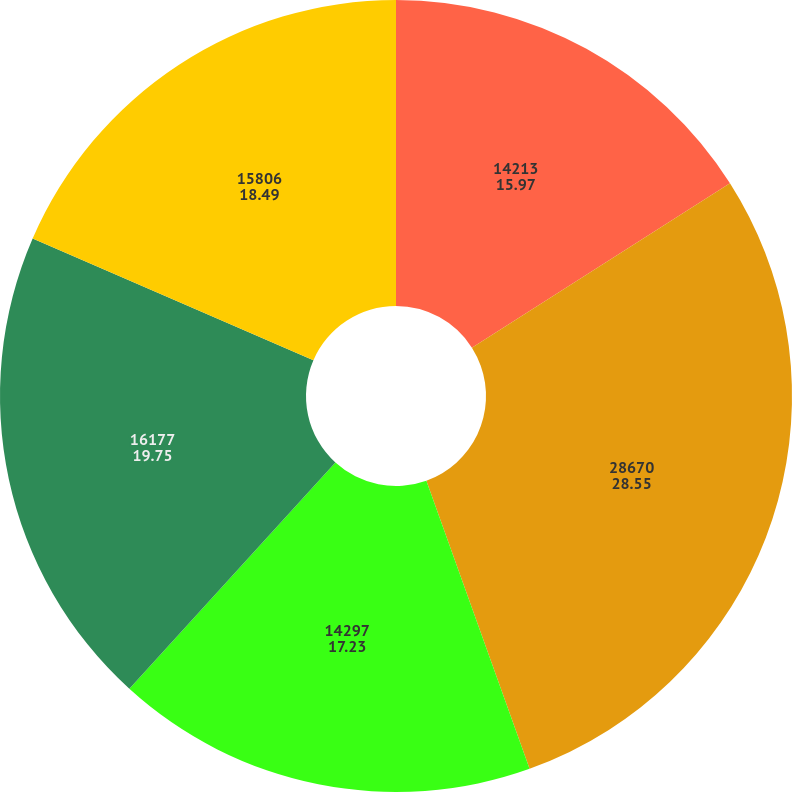Convert chart. <chart><loc_0><loc_0><loc_500><loc_500><pie_chart><fcel>14213<fcel>28670<fcel>14297<fcel>16177<fcel>15806<nl><fcel>15.97%<fcel>28.55%<fcel>17.23%<fcel>19.75%<fcel>18.49%<nl></chart> 